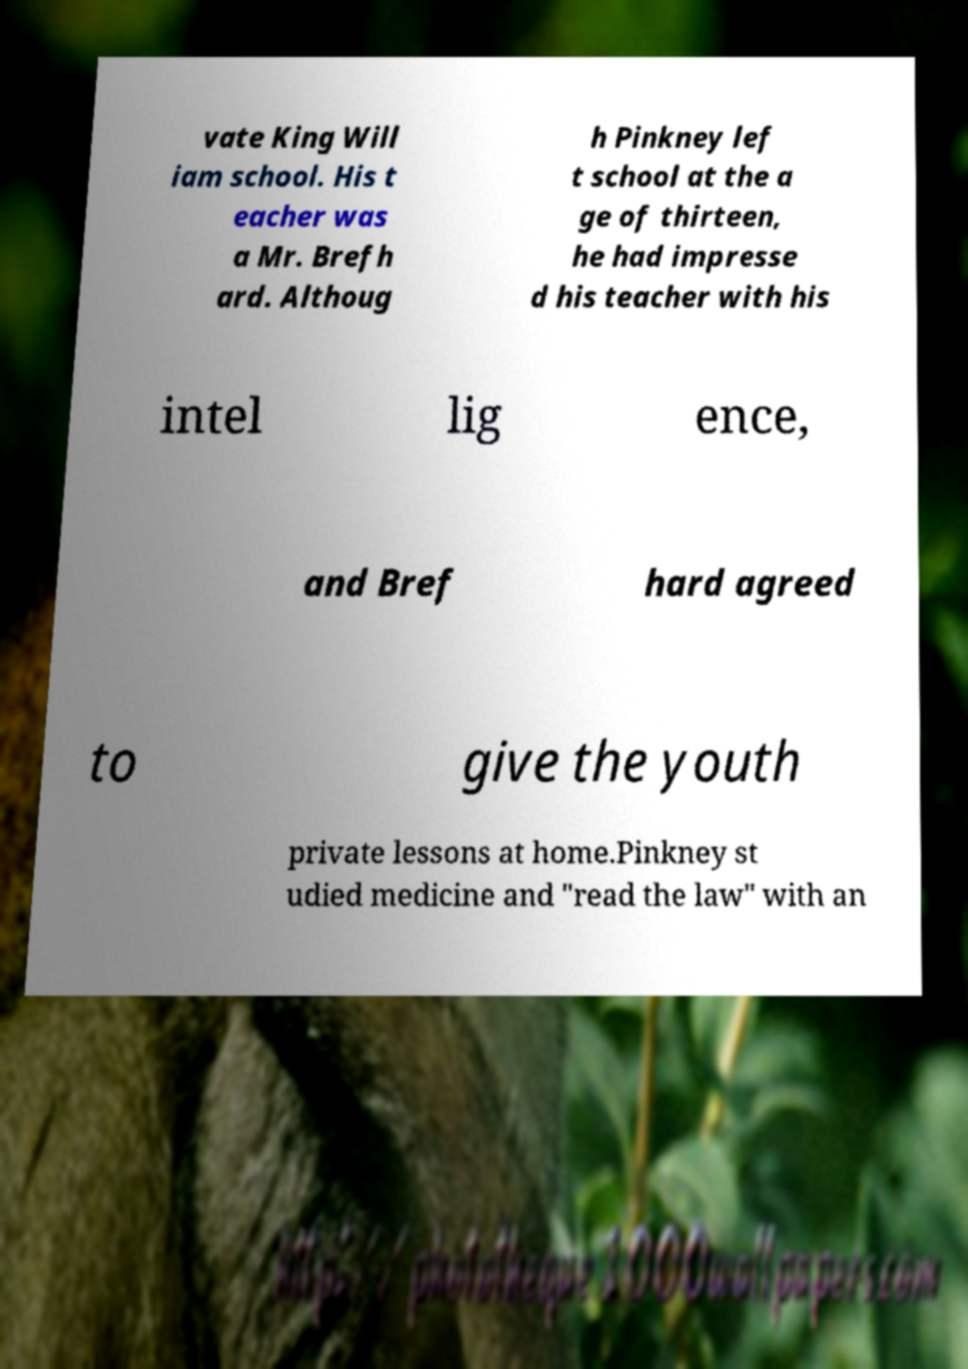For documentation purposes, I need the text within this image transcribed. Could you provide that? vate King Will iam school. His t eacher was a Mr. Brefh ard. Althoug h Pinkney lef t school at the a ge of thirteen, he had impresse d his teacher with his intel lig ence, and Bref hard agreed to give the youth private lessons at home.Pinkney st udied medicine and "read the law" with an 